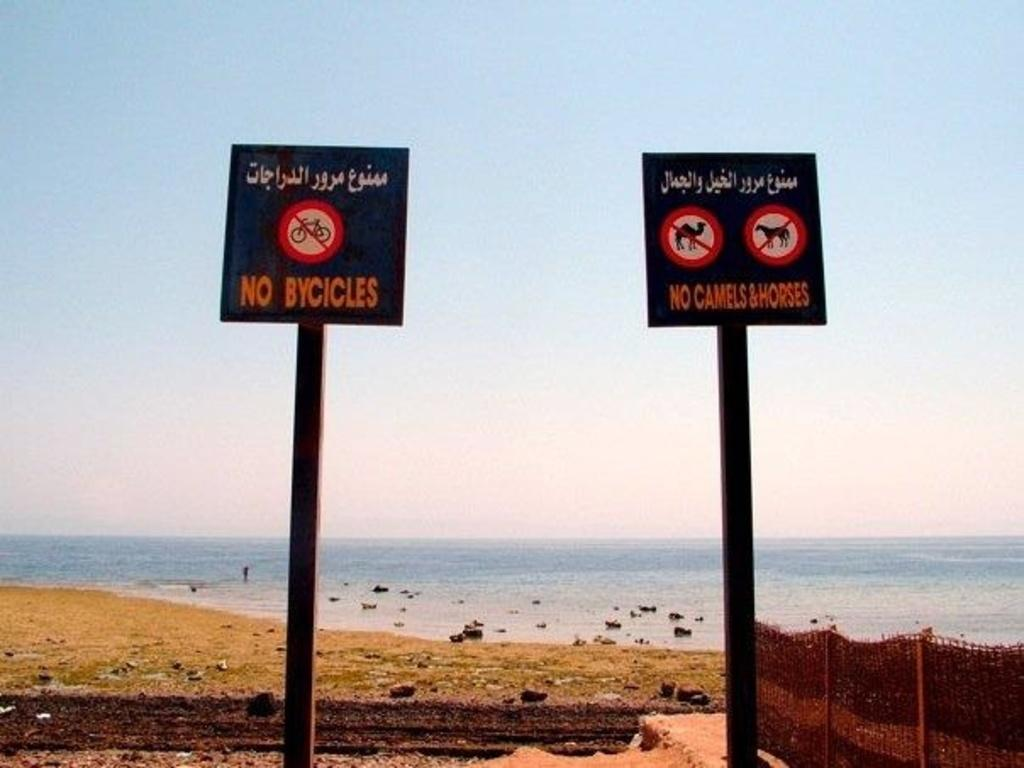<image>
Summarize the visual content of the image. Near a becah, there are two signs that say no bikes and no camels and horses 